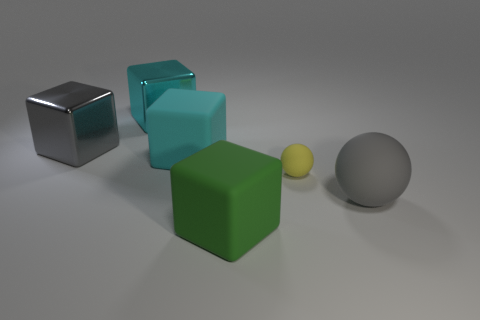Subtract all green matte blocks. How many blocks are left? 3 Add 1 small blue metallic objects. How many objects exist? 7 Subtract all gray cylinders. How many cyan cubes are left? 2 Subtract all green blocks. How many blocks are left? 3 Subtract 1 cubes. How many cubes are left? 3 Subtract all cyan balls. Subtract all yellow cylinders. How many balls are left? 2 Subtract all tiny yellow cylinders. Subtract all large green things. How many objects are left? 5 Add 2 tiny yellow balls. How many tiny yellow balls are left? 3 Add 3 big brown rubber cylinders. How many big brown rubber cylinders exist? 3 Subtract 0 brown blocks. How many objects are left? 6 